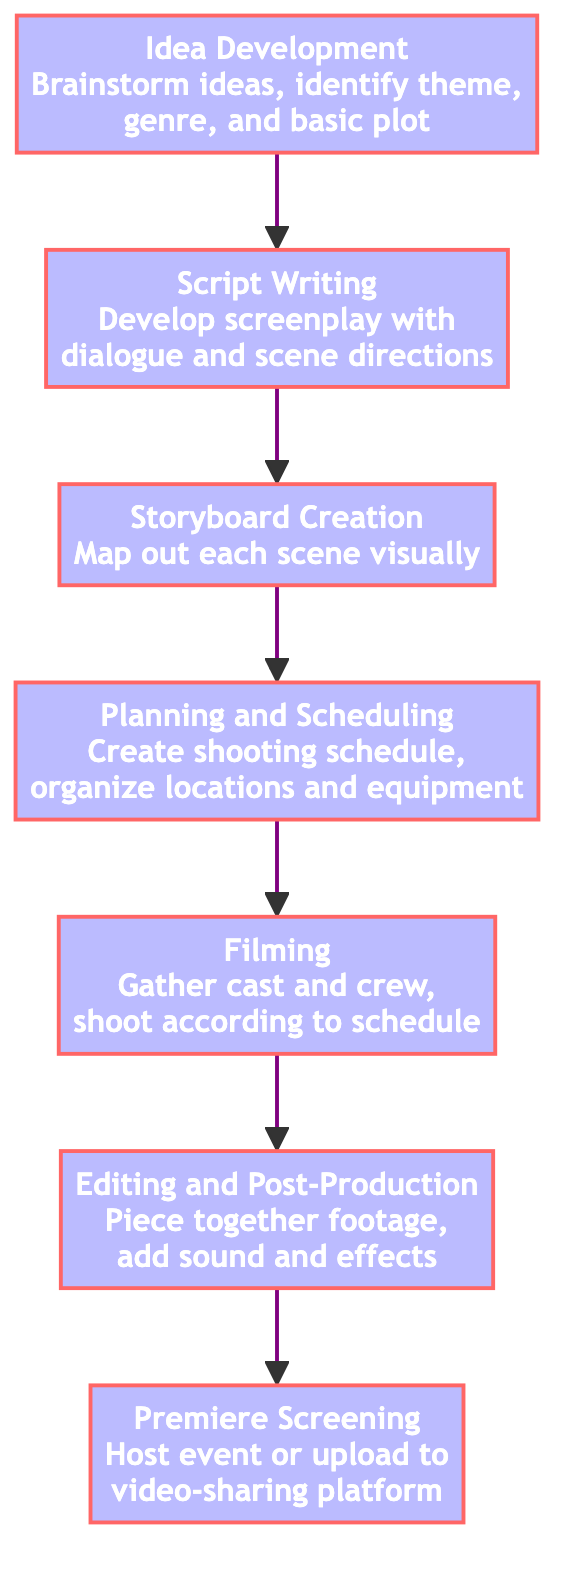what is the final step in the process? The last step in the flow chart is "Premiere Screening." It is at the top of the diagram and has no connections above it.
Answer: Premiere Screening how many nodes are there in the flow chart? Count the number of distinct steps listed in the flow chart. There are seven clearly defined steps from Idea Development to Premiere Screening.
Answer: 7 which step comes immediately after Script Writing? The step that follows "Script Writing" is "Storyboard Creation." This can be determined by looking directly at the connections in the flow chart.
Answer: Storyboard Creation what is the first step in creating a short film? The first step is "Idea Development," as it is at the bottom of the flow chart and the starting point for the process.
Answer: Idea Development how many major production steps are there before the premiere? The steps before the premiere screening include Script Writing, Storyboard Creation, Planning and Scheduling, Filming, and Editing and Post-Production. Counting these gives a total of five steps prior to the final event.
Answer: 5 what is the relationship between Filming and Editing and Post-Production? "Filming" is the step that directly leads into "Editing and Post-Production," which means that the output of the filming phase is used in the editing phase. This shows a direct sequential connection.
Answer: Sequential which step involves creating a visual map of scenes? The step that requires creating a visual map of scenes is "Storyboard Creation," which follows Script Writing in the overall process.
Answer: Storyboard Creation after Filming, what is the next step in the workflow? The step that occurs immediately after Filming is "Editing and Post-Production." This is indicated by the directional flow from Filming to Editing in the chart.
Answer: Editing and Post-Production what is the main purpose of the Editing and Post-Production step? The main goal of "Editing and Post-Production" is to piece together footage, add sound, and apply effects, making it a critical process for finalizing the film.
Answer: Finalize the film 